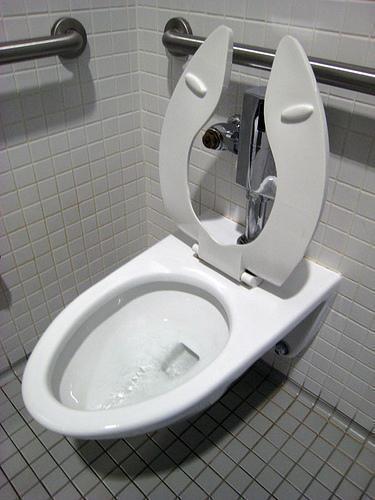How many people have gray hair?
Give a very brief answer. 0. 